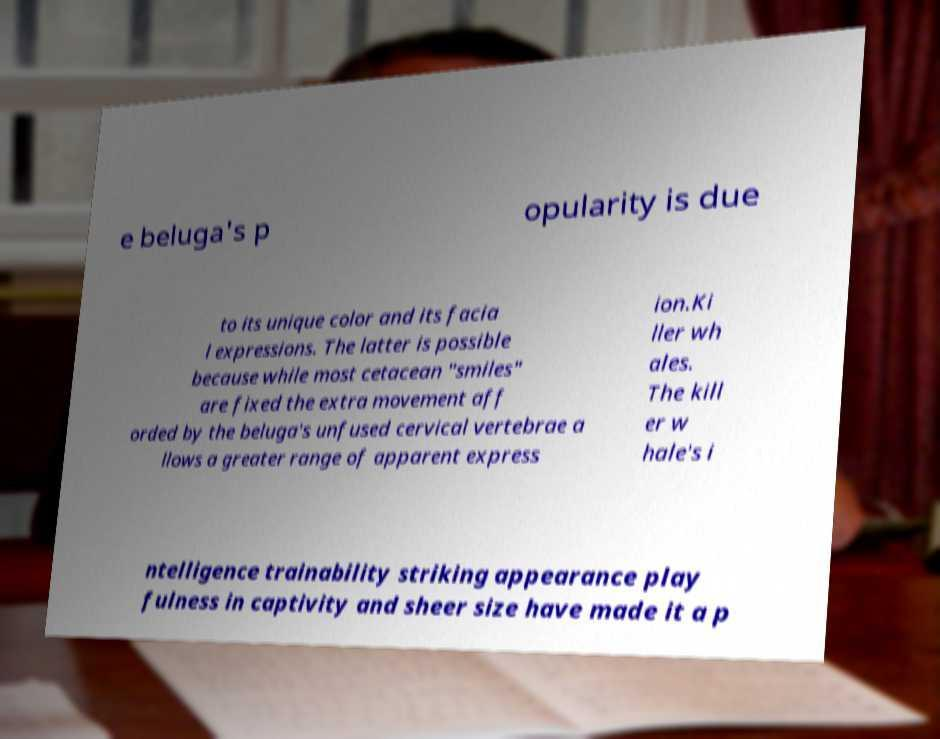What messages or text are displayed in this image? I need them in a readable, typed format. e beluga's p opularity is due to its unique color and its facia l expressions. The latter is possible because while most cetacean "smiles" are fixed the extra movement aff orded by the beluga's unfused cervical vertebrae a llows a greater range of apparent express ion.Ki ller wh ales. The kill er w hale's i ntelligence trainability striking appearance play fulness in captivity and sheer size have made it a p 